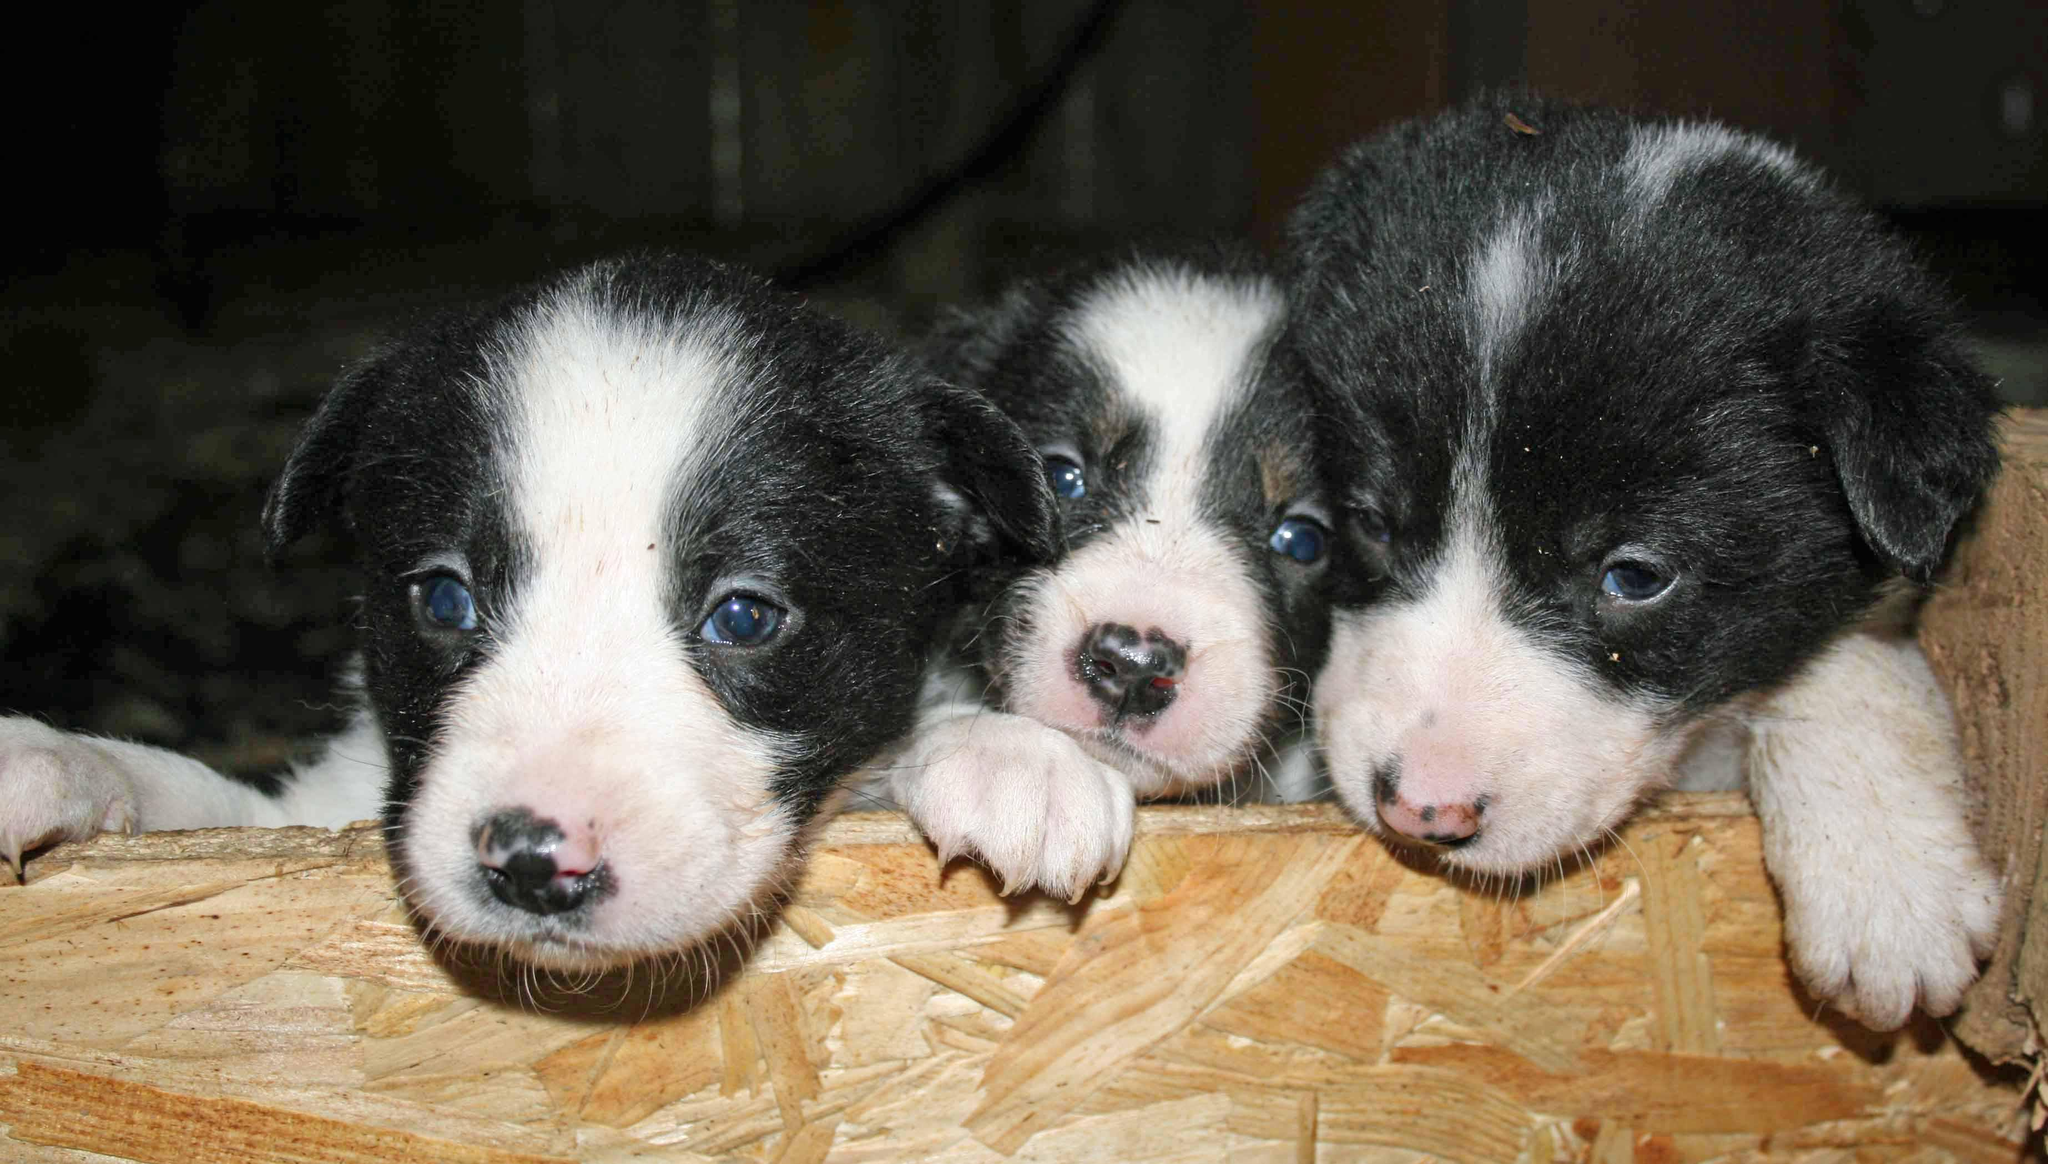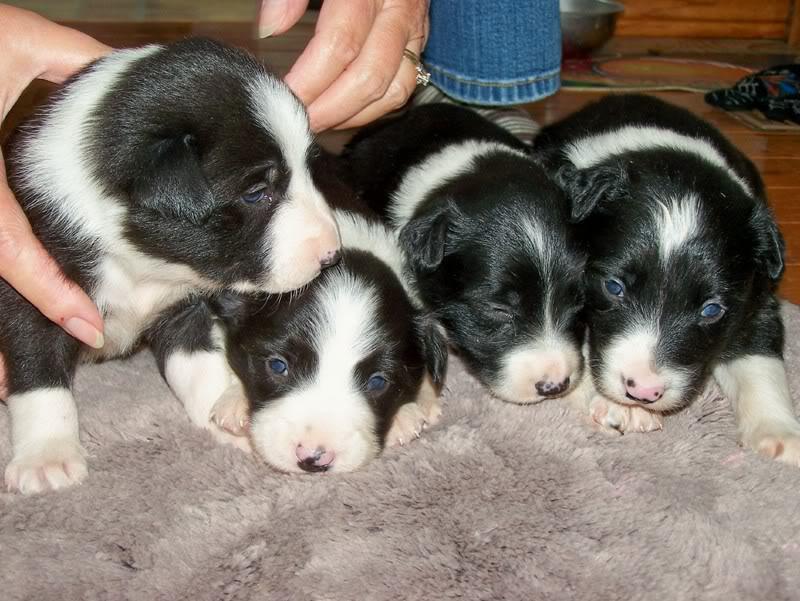The first image is the image on the left, the second image is the image on the right. Analyze the images presented: Is the assertion "An image contains a single black-and-white dog, which is sitting up and looking intently at something." valid? Answer yes or no. No. The first image is the image on the left, the second image is the image on the right. Assess this claim about the two images: "The right image contains at least three dogs.". Correct or not? Answer yes or no. Yes. 